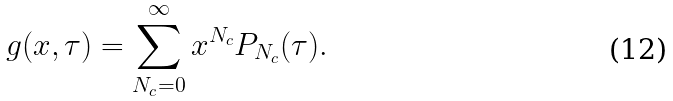Convert formula to latex. <formula><loc_0><loc_0><loc_500><loc_500>g ( x , \tau ) = \sum _ { N _ { c } = 0 } ^ { \infty } x ^ { N _ { c } } P _ { N _ { c } } ( \tau ) .</formula> 